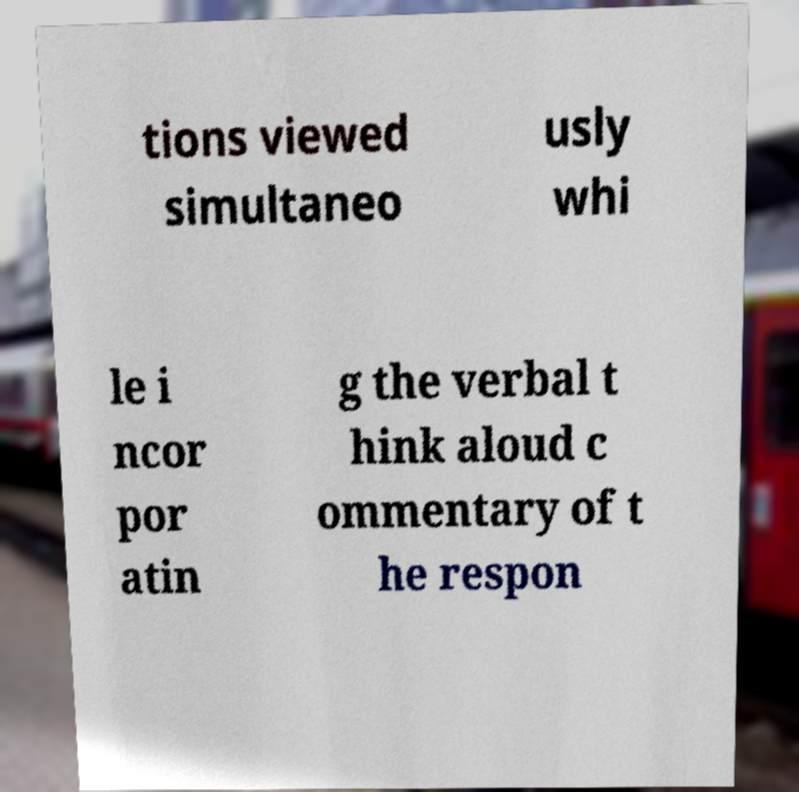Can you read and provide the text displayed in the image?This photo seems to have some interesting text. Can you extract and type it out for me? tions viewed simultaneo usly whi le i ncor por atin g the verbal t hink aloud c ommentary of t he respon 